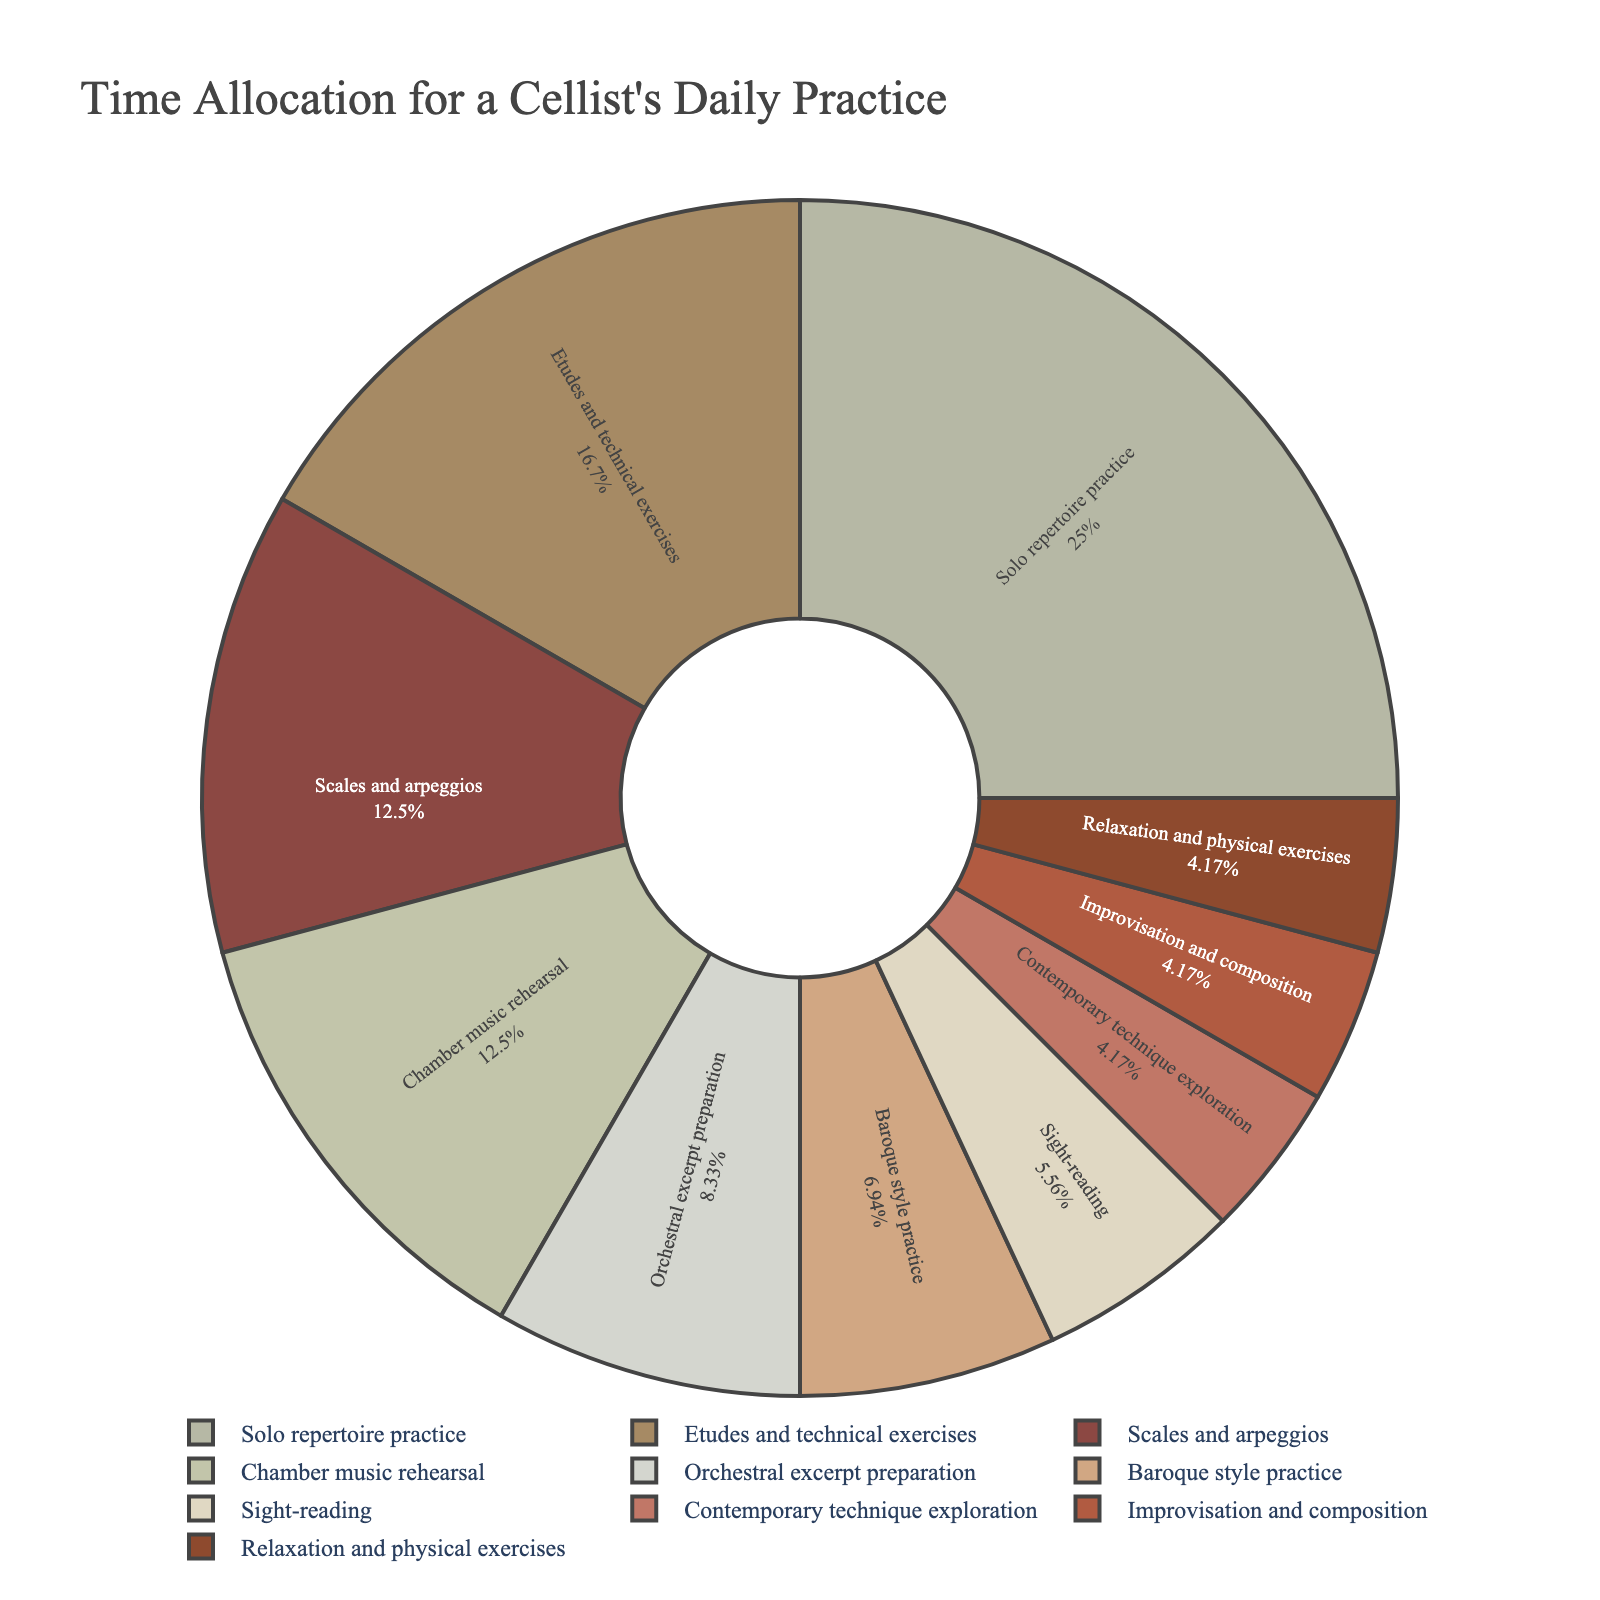What category has the highest time allocation? The figure indicates that the category with the largest segment represents the highest time allocation. "Solo repertoire practice" has the highest time allocation since its segment is the largest.
Answer: Solo repertoire practice Compare the time allocated to "Etudes and technical exercises" with "Orchestral excerpt preparation". Which one gets more? By comparing the sizes of the two segments, we see that "Etudes and technical exercises" has a larger segment than "Orchestral excerpt preparation", indicating more time allocated to it.
Answer: Etudes and technical exercises What percentage of the total practice time is dedicated to "Sight-reading" and "Contemporary technique exploration"? By looking at the pie chart, identify the segments corresponding to "Sight-reading" and "Contemporary technique exploration" and sum their percentages. The segments show 8% for "Sight-reading" and 6% for "Contemporary technique exploration," totaling 14%.
Answer: 14% Which activities combined make up exactly half of the total practice time? Identify segments that, when summed, equal 50%. "Solo repertoire practice" (30%) and "Etudes and technical exercises" (20%) together account for 50% of the practice time.
Answer: Solo repertoire practice and Etudes and technical exercises What is the difference in time allocation between "Scales and arpeggios" and "Baroque style practice"? Locate the segments and note the percentage values. "Scales and arpeggios" are allocated 15% and "Baroque style practice" 8.3%. The difference is 15% - 8.3% = 6.7%.
Answer: 6.7% Is more time spent on "Chamber music rehearsal" or "Improvisation and composition"? Compare the sizes of the two applicable pie segments. "Chamber music rehearsal" has a larger slice than "Improvisation and composition," indicating more time spent on it.
Answer: Chamber music rehearsal What is the total time allocated to activities with less than 30 minutes each? Sum the times of "Sight-reading" (20), "Baroque style practice" (25), "Contemporary technique exploration" (15), "Improvisation and composition" (15), "Relaxation and physical exercises" (15). Total is 20 + 25 + 15 + 15 + 15 = 90 minutes.
Answer: 90 minutes Which category representing approximately 10% of the total practice time, stands out with a distinct green-tinted segment? Identify the segment close to 10% and note its color. "Scales and arpeggios" stands out with a green-tinted segment, representing around 10% of the pie chart.
Answer: Scales and arpeggios What's the ratio of time spent on "Solo repertoire practice" to "Relaxation and physical exercises"? Calculate the ratio between their assigned minutes. "Solo repertoire practice" is 90 minutes and "Relaxation and physical exercises" is 15 minutes. The ratio is 90:15 or 6:1.
Answer: 6:1 